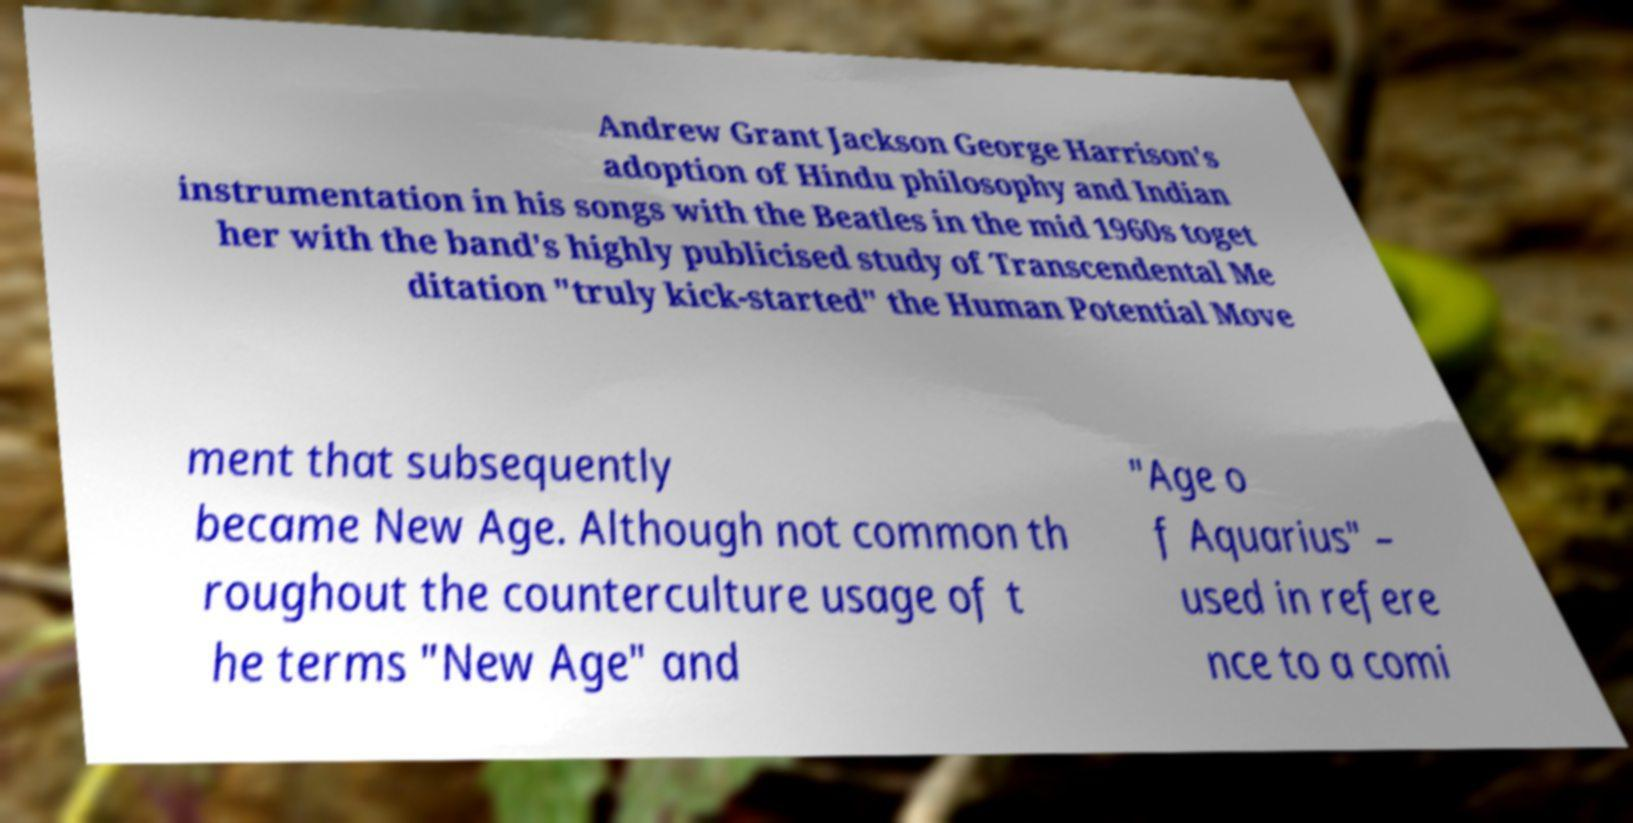Could you assist in decoding the text presented in this image and type it out clearly? Andrew Grant Jackson George Harrison's adoption of Hindu philosophy and Indian instrumentation in his songs with the Beatles in the mid 1960s toget her with the band's highly publicised study of Transcendental Me ditation "truly kick-started" the Human Potential Move ment that subsequently became New Age. Although not common th roughout the counterculture usage of t he terms "New Age" and "Age o f Aquarius" – used in refere nce to a comi 